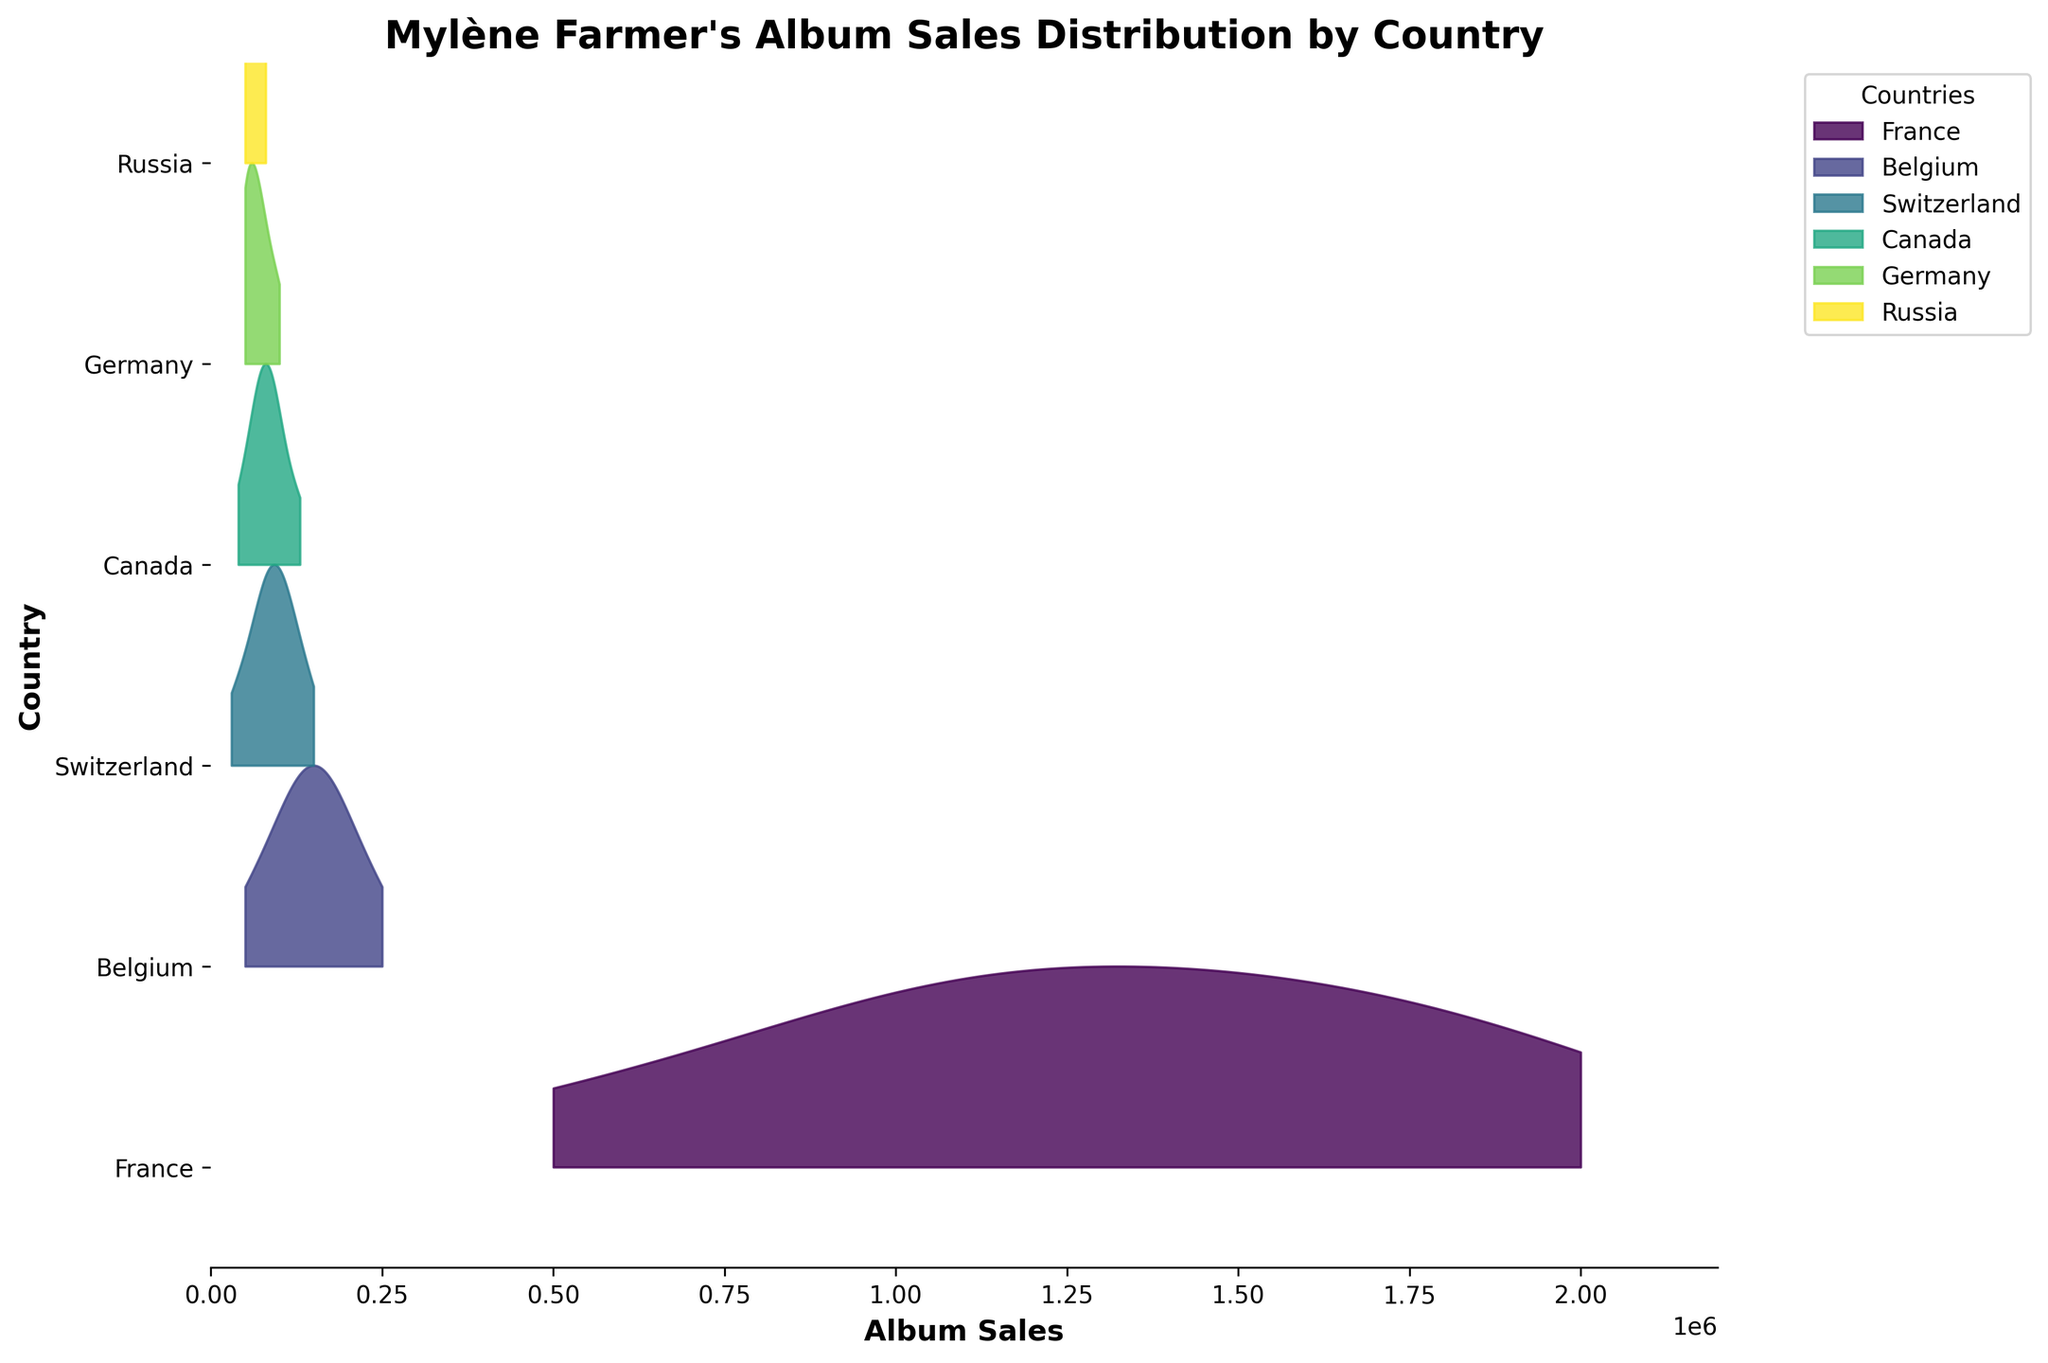What's the title of the plot? The title of the plot is usually placed at the top center of the figure. In this case, it should be "Mylène Farmer's Album Sales Distribution by Country" as mentioned in the code.
Answer: Mylène Farmer's Album Sales Distribution by Country What is the y-axis representing in this plot? The y-axis represents the different countries where Mylène Farmer's album sales were recorded. This can be inferred by looking at the list of labels on the y-axis.
Answer: Different countries Which country appears to have the highest album sales distribution consistently across the years? By observing the distribution and the range of album sales, France consistently shows the highest album sales in every year. This is apparent from the larger filled areas on the chart for France compared to other countries.
Answer: France How many unique countries are represented in the distribution? The number of unique countries can be found by counting the distinct filled lines on the y-axis. In the code, it refers to 'countries = data['Country'].unique()', which lists distinct country names.
Answer: 7 What is the maximum album sales figure for any single year in the plot? By examining the x-axis, the maximum album sales figure can be identified. The data shows 2,000,000 sales in 1999 for France, which is the highest.
Answer: 2,000,000 In which year did Mylène Farmer's album sales in Germany first appear? By examining the position of the points along the x-axis for Germany, we can trace the earliest year that album sales in Germany are plotted. The first appearance is in 1991.
Answer: 1991 Compare the album sales distribution in 2005 between France and Belgium. Which one had higher sales, and by how much? By looking at the distributions for France and Belgium in 2005, France has higher sales. The sales for France and Belgium are 1,500,000 and 180,000, respectively. The difference is 1,500,000 - 180,000 = 1,320,000.
Answer: France by 1,320,000 Did Mylène Farmer's album sales in Canada ever exceed 100,000 units in any year? By observing the distribution for Canada across the years, the sales in 1995 exceed 100,000 units, as evident from the data.
Answer: Yes Which two countries had similar album sales distributions in 2010? By comparing the distributions for different countries in 2010, Belgium and Switzerland have similar sales distributions. Both reach around 90,000 units.
Answer: Belgium and Switzerland How did the album sales distribution in Russia change from 1999 to 2015? By examining the filled areas and their values for Russia in 1999, 2005, 2010, and 2015, one can see changes in the sales figures. In 1999, it was 50,000, increasing slightly over the years to about 80,000 in 2015.
Answer: Increased from 50,000 to 80,000 